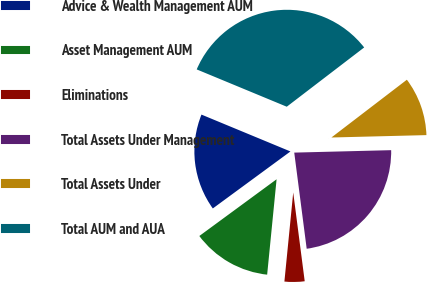Convert chart to OTSL. <chart><loc_0><loc_0><loc_500><loc_500><pie_chart><fcel>Advice & Wealth Management AUM<fcel>Asset Management AUM<fcel>Eliminations<fcel>Total Assets Under Management<fcel>Total Assets Under<fcel>Total AUM and AUA<nl><fcel>16.33%<fcel>13.35%<fcel>3.62%<fcel>23.35%<fcel>10.0%<fcel>33.35%<nl></chart> 